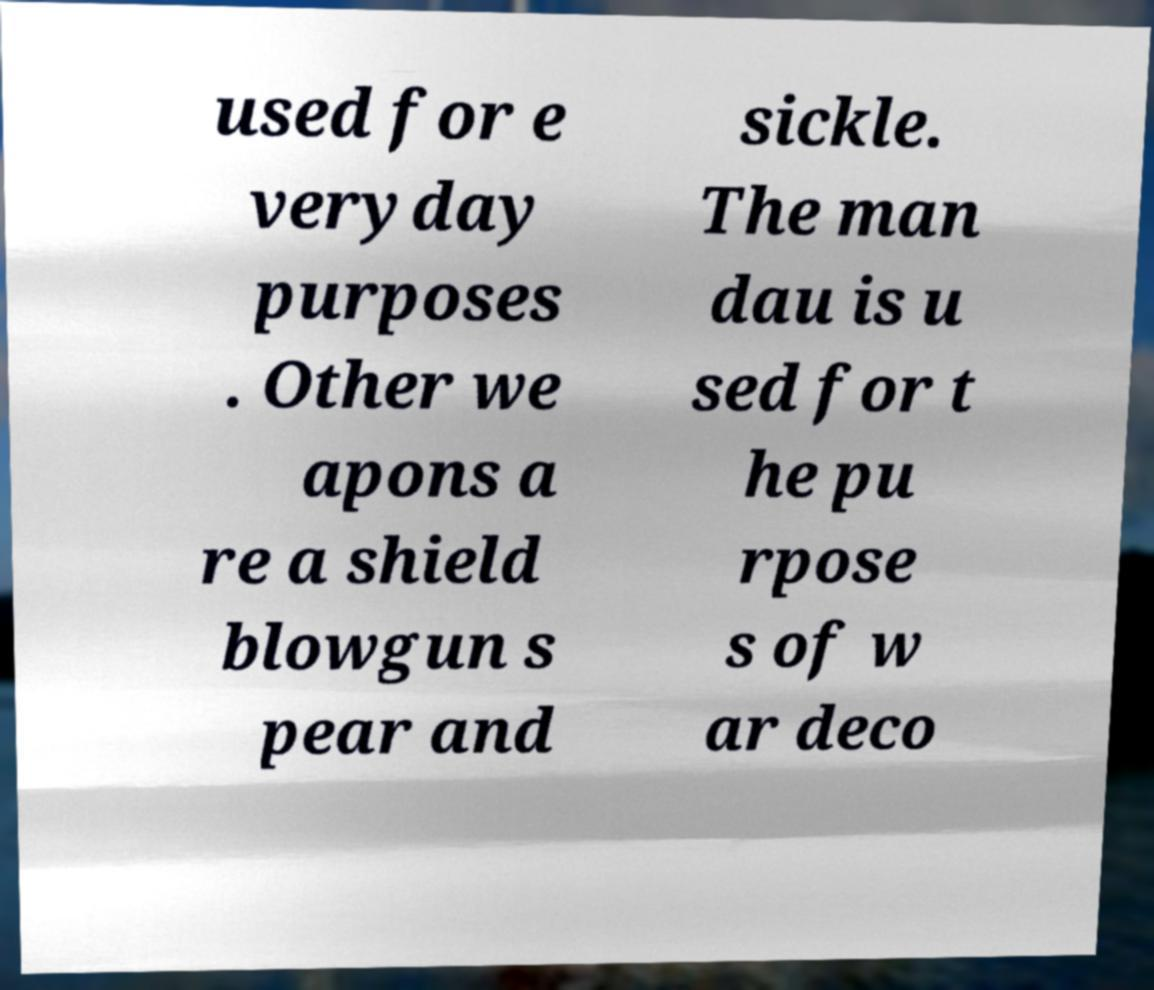Could you assist in decoding the text presented in this image and type it out clearly? used for e veryday purposes . Other we apons a re a shield blowgun s pear and sickle. The man dau is u sed for t he pu rpose s of w ar deco 